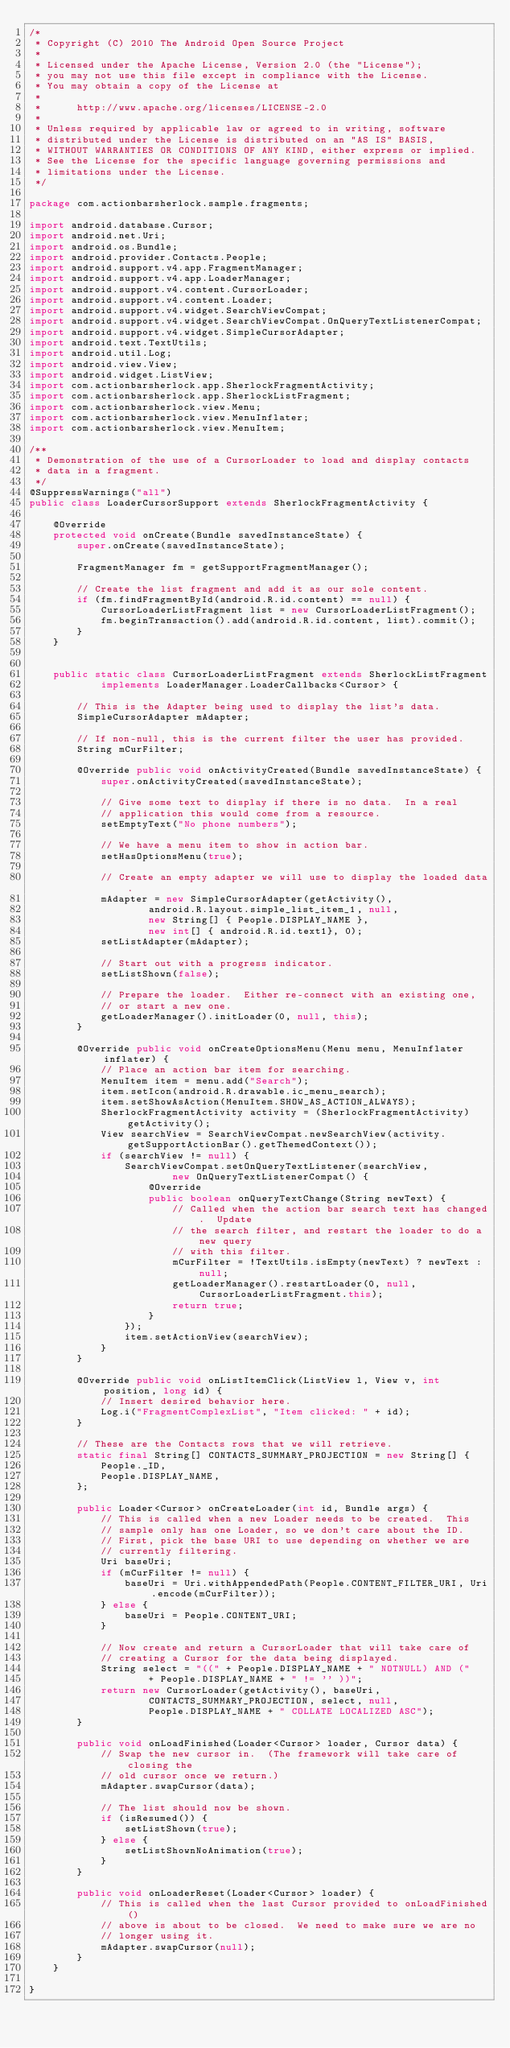Convert code to text. <code><loc_0><loc_0><loc_500><loc_500><_Java_>/*
 * Copyright (C) 2010 The Android Open Source Project
 *
 * Licensed under the Apache License, Version 2.0 (the "License");
 * you may not use this file except in compliance with the License.
 * You may obtain a copy of the License at
 *
 *      http://www.apache.org/licenses/LICENSE-2.0
 *
 * Unless required by applicable law or agreed to in writing, software
 * distributed under the License is distributed on an "AS IS" BASIS,
 * WITHOUT WARRANTIES OR CONDITIONS OF ANY KIND, either express or implied.
 * See the License for the specific language governing permissions and
 * limitations under the License.
 */

package com.actionbarsherlock.sample.fragments;

import android.database.Cursor;
import android.net.Uri;
import android.os.Bundle;
import android.provider.Contacts.People;
import android.support.v4.app.FragmentManager;
import android.support.v4.app.LoaderManager;
import android.support.v4.content.CursorLoader;
import android.support.v4.content.Loader;
import android.support.v4.widget.SearchViewCompat;
import android.support.v4.widget.SearchViewCompat.OnQueryTextListenerCompat;
import android.support.v4.widget.SimpleCursorAdapter;
import android.text.TextUtils;
import android.util.Log;
import android.view.View;
import android.widget.ListView;
import com.actionbarsherlock.app.SherlockFragmentActivity;
import com.actionbarsherlock.app.SherlockListFragment;
import com.actionbarsherlock.view.Menu;
import com.actionbarsherlock.view.MenuInflater;
import com.actionbarsherlock.view.MenuItem;

/**
 * Demonstration of the use of a CursorLoader to load and display contacts
 * data in a fragment.
 */
@SuppressWarnings("all")
public class LoaderCursorSupport extends SherlockFragmentActivity {

    @Override
    protected void onCreate(Bundle savedInstanceState) {
        super.onCreate(savedInstanceState);

        FragmentManager fm = getSupportFragmentManager();

        // Create the list fragment and add it as our sole content.
        if (fm.findFragmentById(android.R.id.content) == null) {
            CursorLoaderListFragment list = new CursorLoaderListFragment();
            fm.beginTransaction().add(android.R.id.content, list).commit();
        }
    }


    public static class CursorLoaderListFragment extends SherlockListFragment
            implements LoaderManager.LoaderCallbacks<Cursor> {

        // This is the Adapter being used to display the list's data.
        SimpleCursorAdapter mAdapter;

        // If non-null, this is the current filter the user has provided.
        String mCurFilter;

        @Override public void onActivityCreated(Bundle savedInstanceState) {
            super.onActivityCreated(savedInstanceState);

            // Give some text to display if there is no data.  In a real
            // application this would come from a resource.
            setEmptyText("No phone numbers");

            // We have a menu item to show in action bar.
            setHasOptionsMenu(true);

            // Create an empty adapter we will use to display the loaded data.
            mAdapter = new SimpleCursorAdapter(getActivity(),
                    android.R.layout.simple_list_item_1, null,
                    new String[] { People.DISPLAY_NAME },
                    new int[] { android.R.id.text1}, 0);
            setListAdapter(mAdapter);

            // Start out with a progress indicator.
            setListShown(false);

            // Prepare the loader.  Either re-connect with an existing one,
            // or start a new one.
            getLoaderManager().initLoader(0, null, this);
        }

        @Override public void onCreateOptionsMenu(Menu menu, MenuInflater inflater) {
            // Place an action bar item for searching.
            MenuItem item = menu.add("Search");
            item.setIcon(android.R.drawable.ic_menu_search);
            item.setShowAsAction(MenuItem.SHOW_AS_ACTION_ALWAYS);
            SherlockFragmentActivity activity = (SherlockFragmentActivity)getActivity();
            View searchView = SearchViewCompat.newSearchView(activity.getSupportActionBar().getThemedContext());
            if (searchView != null) {
                SearchViewCompat.setOnQueryTextListener(searchView,
                        new OnQueryTextListenerCompat() {
                    @Override
                    public boolean onQueryTextChange(String newText) {
                        // Called when the action bar search text has changed.  Update
                        // the search filter, and restart the loader to do a new query
                        // with this filter.
                        mCurFilter = !TextUtils.isEmpty(newText) ? newText : null;
                        getLoaderManager().restartLoader(0, null, CursorLoaderListFragment.this);
                        return true;
                    }
                });
                item.setActionView(searchView);
            }
        }

        @Override public void onListItemClick(ListView l, View v, int position, long id) {
            // Insert desired behavior here.
            Log.i("FragmentComplexList", "Item clicked: " + id);
        }

        // These are the Contacts rows that we will retrieve.
        static final String[] CONTACTS_SUMMARY_PROJECTION = new String[] {
            People._ID,
            People.DISPLAY_NAME,
        };

        public Loader<Cursor> onCreateLoader(int id, Bundle args) {
            // This is called when a new Loader needs to be created.  This
            // sample only has one Loader, so we don't care about the ID.
            // First, pick the base URI to use depending on whether we are
            // currently filtering.
            Uri baseUri;
            if (mCurFilter != null) {
                baseUri = Uri.withAppendedPath(People.CONTENT_FILTER_URI, Uri.encode(mCurFilter));
            } else {
                baseUri = People.CONTENT_URI;
            }

            // Now create and return a CursorLoader that will take care of
            // creating a Cursor for the data being displayed.
            String select = "((" + People.DISPLAY_NAME + " NOTNULL) AND ("
                    + People.DISPLAY_NAME + " != '' ))";
            return new CursorLoader(getActivity(), baseUri,
                    CONTACTS_SUMMARY_PROJECTION, select, null,
                    People.DISPLAY_NAME + " COLLATE LOCALIZED ASC");
        }

        public void onLoadFinished(Loader<Cursor> loader, Cursor data) {
            // Swap the new cursor in.  (The framework will take care of closing the
            // old cursor once we return.)
            mAdapter.swapCursor(data);

            // The list should now be shown.
            if (isResumed()) {
                setListShown(true);
            } else {
                setListShownNoAnimation(true);
            }
        }

        public void onLoaderReset(Loader<Cursor> loader) {
            // This is called when the last Cursor provided to onLoadFinished()
            // above is about to be closed.  We need to make sure we are no
            // longer using it.
            mAdapter.swapCursor(null);
        }
    }

}
</code> 